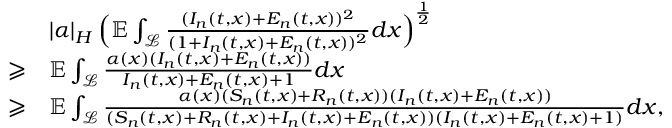Convert formula to latex. <formula><loc_0><loc_0><loc_500><loc_500>\begin{array} { r l } & { \left | \alpha \right | _ { H } \left ( \mathbb { E } \int _ { \mathcal { L } } \frac { ( I _ { n } ( t , x ) + E _ { n } ( t , x ) ) ^ { 2 } } { ( 1 + I _ { n } ( t , x ) + E _ { n } ( t , x ) ) ^ { 2 } } d x \right ) ^ { \frac { 1 } { 2 } } } \\ { \geqslant } & { \mathbb { E } \int _ { \mathcal { L } } \frac { \alpha ( x ) ( I _ { n } ( t , x ) + E _ { n } ( t , x ) ) } { I _ { n } ( t , x ) + E _ { n } ( t , x ) + 1 } d x } \\ { \geqslant } & { \mathbb { E } \int _ { \mathcal { L } } \frac { \alpha ( x ) ( S _ { n } ( t , x ) + R _ { n } ( t , x ) ) ( I _ { n } ( t , x ) + E _ { n } ( t , x ) ) } { ( S _ { n } ( t , x ) + R _ { n } ( t , x ) + I _ { n } ( t , x ) + E _ { n } ( t , x ) ) ( I _ { n } ( t , x ) + E _ { n } ( t , x ) + 1 ) } d x , } \end{array}</formula> 